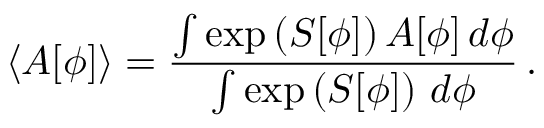<formula> <loc_0><loc_0><loc_500><loc_500>\langle A [ \phi ] \rangle = \frac { \int \exp \left ( S [ \phi ] \right ) A [ \phi ] \, d \phi } { \int \exp \left ( S [ \phi ] \right ) \, d \phi } \, .</formula> 